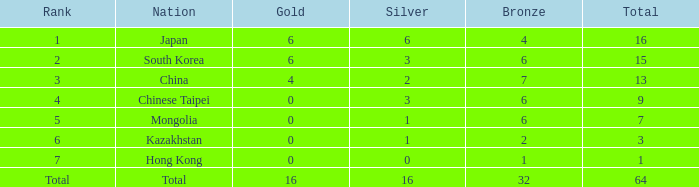Which Silver has a Nation of china, and a Bronze smaller than 7? None. 